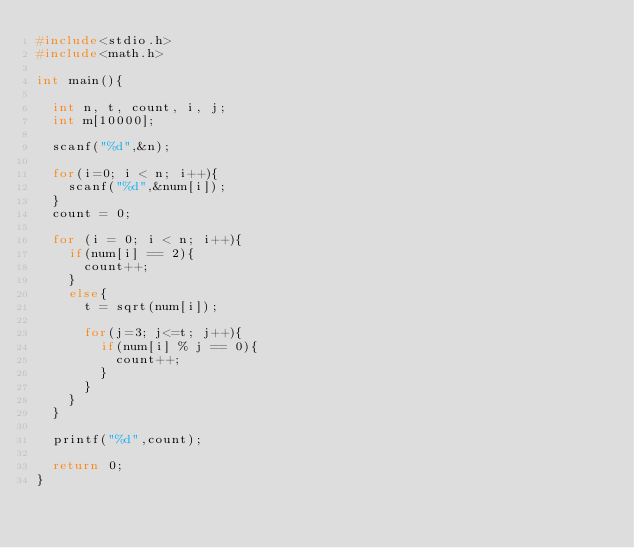Convert code to text. <code><loc_0><loc_0><loc_500><loc_500><_C_>#include<stdio.h>
#include<math.h>

int main(){

  int n, t, count, i, j;
  int m[10000];

  scanf("%d",&n);

  for(i=0; i < n; i++){
    scanf("%d",&num[i]);
  }
  count = 0;

  for (i = 0; i < n; i++){
    if(num[i] == 2){
      count++;
    }
    else{
      t = sqrt(num[i]);
    
      for(j=3; j<=t; j++){
        if(num[i] % j == 0){
          count++;    
        }
      }  
    }
  }

  printf("%d",count);

  return 0;
}</code> 